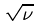Convert formula to latex. <formula><loc_0><loc_0><loc_500><loc_500>\sqrt { \nu }</formula> 